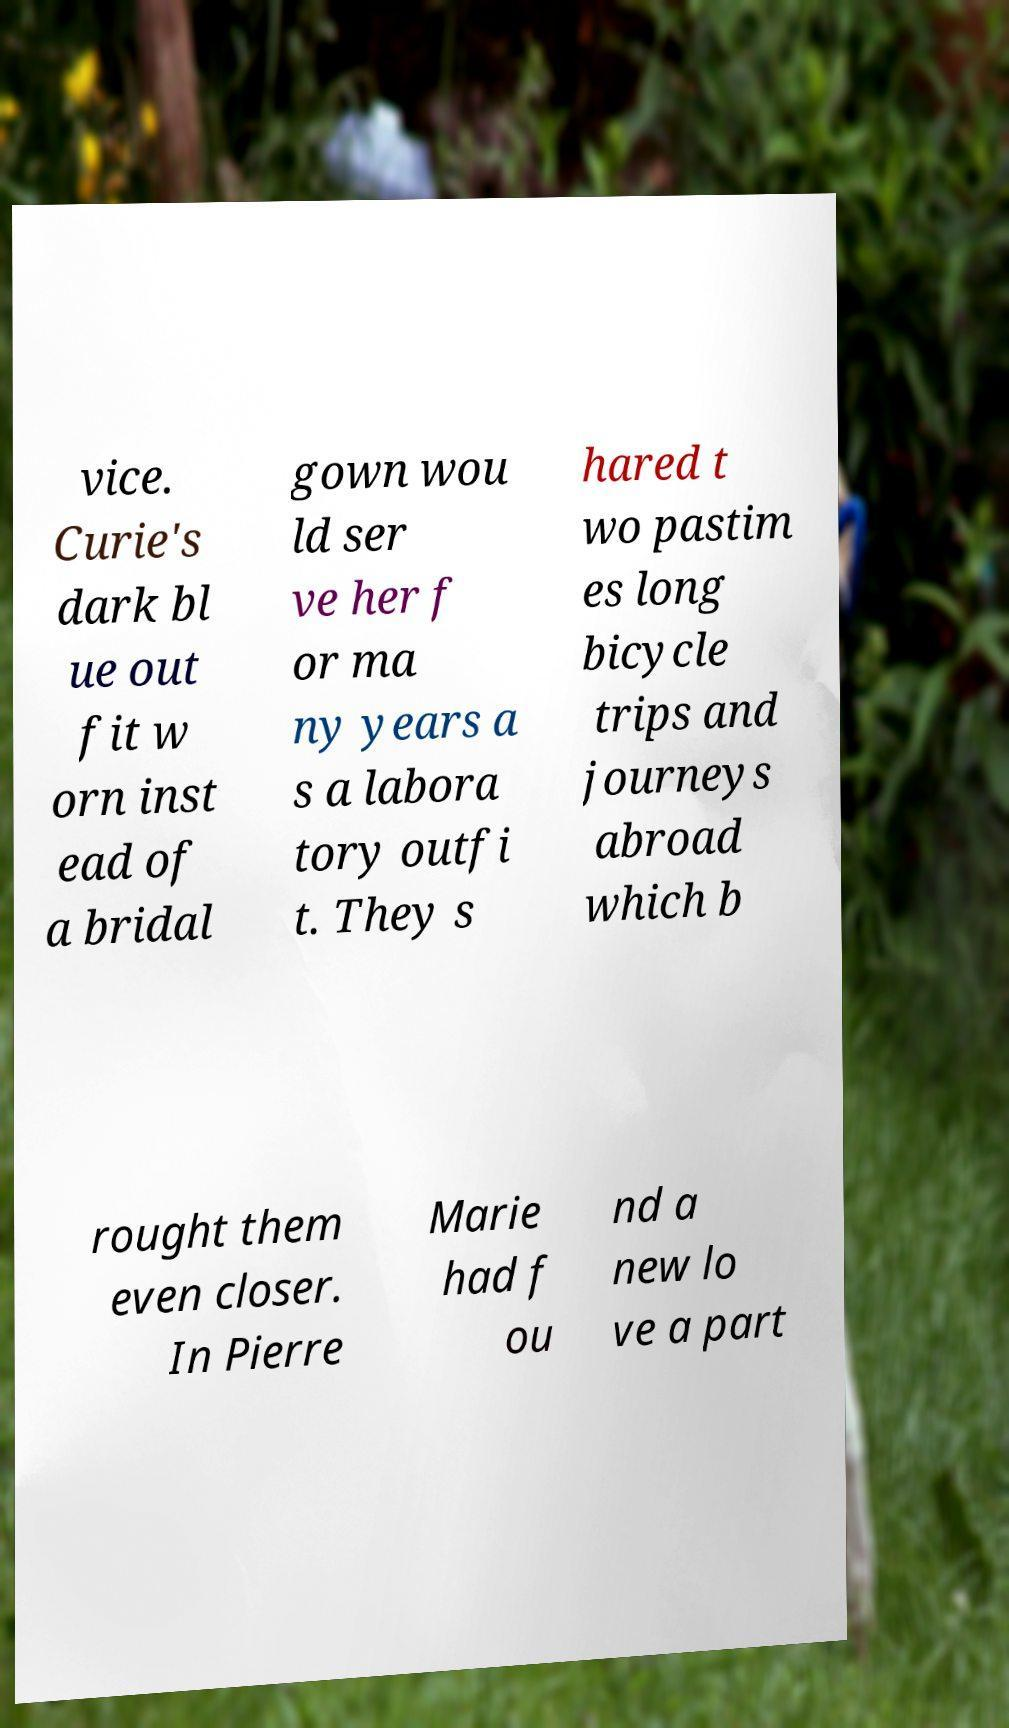Could you assist in decoding the text presented in this image and type it out clearly? vice. Curie's dark bl ue out fit w orn inst ead of a bridal gown wou ld ser ve her f or ma ny years a s a labora tory outfi t. They s hared t wo pastim es long bicycle trips and journeys abroad which b rought them even closer. In Pierre Marie had f ou nd a new lo ve a part 